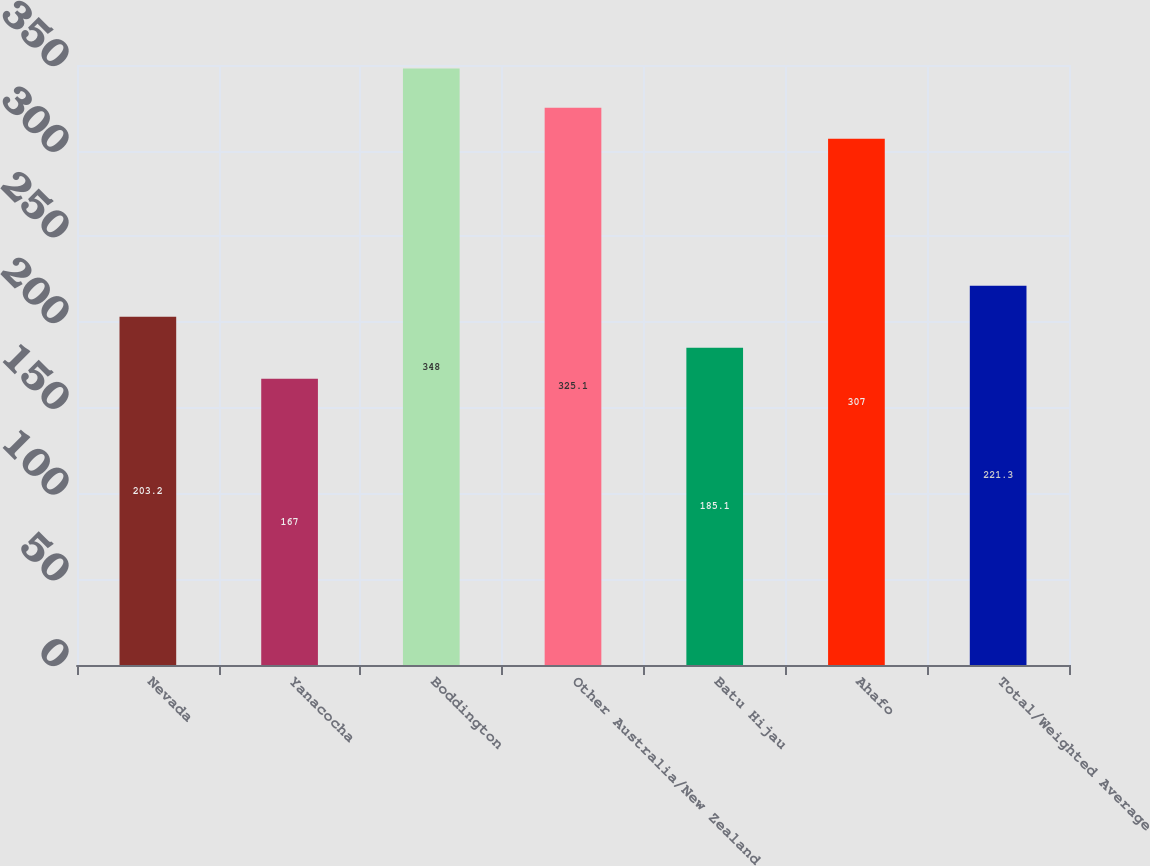<chart> <loc_0><loc_0><loc_500><loc_500><bar_chart><fcel>Nevada<fcel>Yanacocha<fcel>Boddington<fcel>Other Australia/New Zealand<fcel>Batu Hijau<fcel>Ahafo<fcel>Total/Weighted Average<nl><fcel>203.2<fcel>167<fcel>348<fcel>325.1<fcel>185.1<fcel>307<fcel>221.3<nl></chart> 